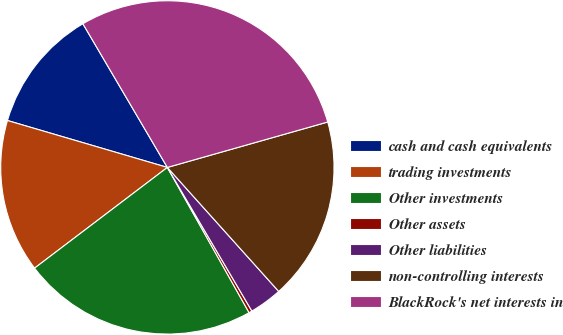Convert chart. <chart><loc_0><loc_0><loc_500><loc_500><pie_chart><fcel>cash and cash equivalents<fcel>trading investments<fcel>Other investments<fcel>Other assets<fcel>Other liabilities<fcel>non-controlling interests<fcel>BlackRock's net interests in<nl><fcel>12.0%<fcel>14.87%<fcel>22.83%<fcel>0.31%<fcel>3.18%<fcel>17.75%<fcel>29.07%<nl></chart> 